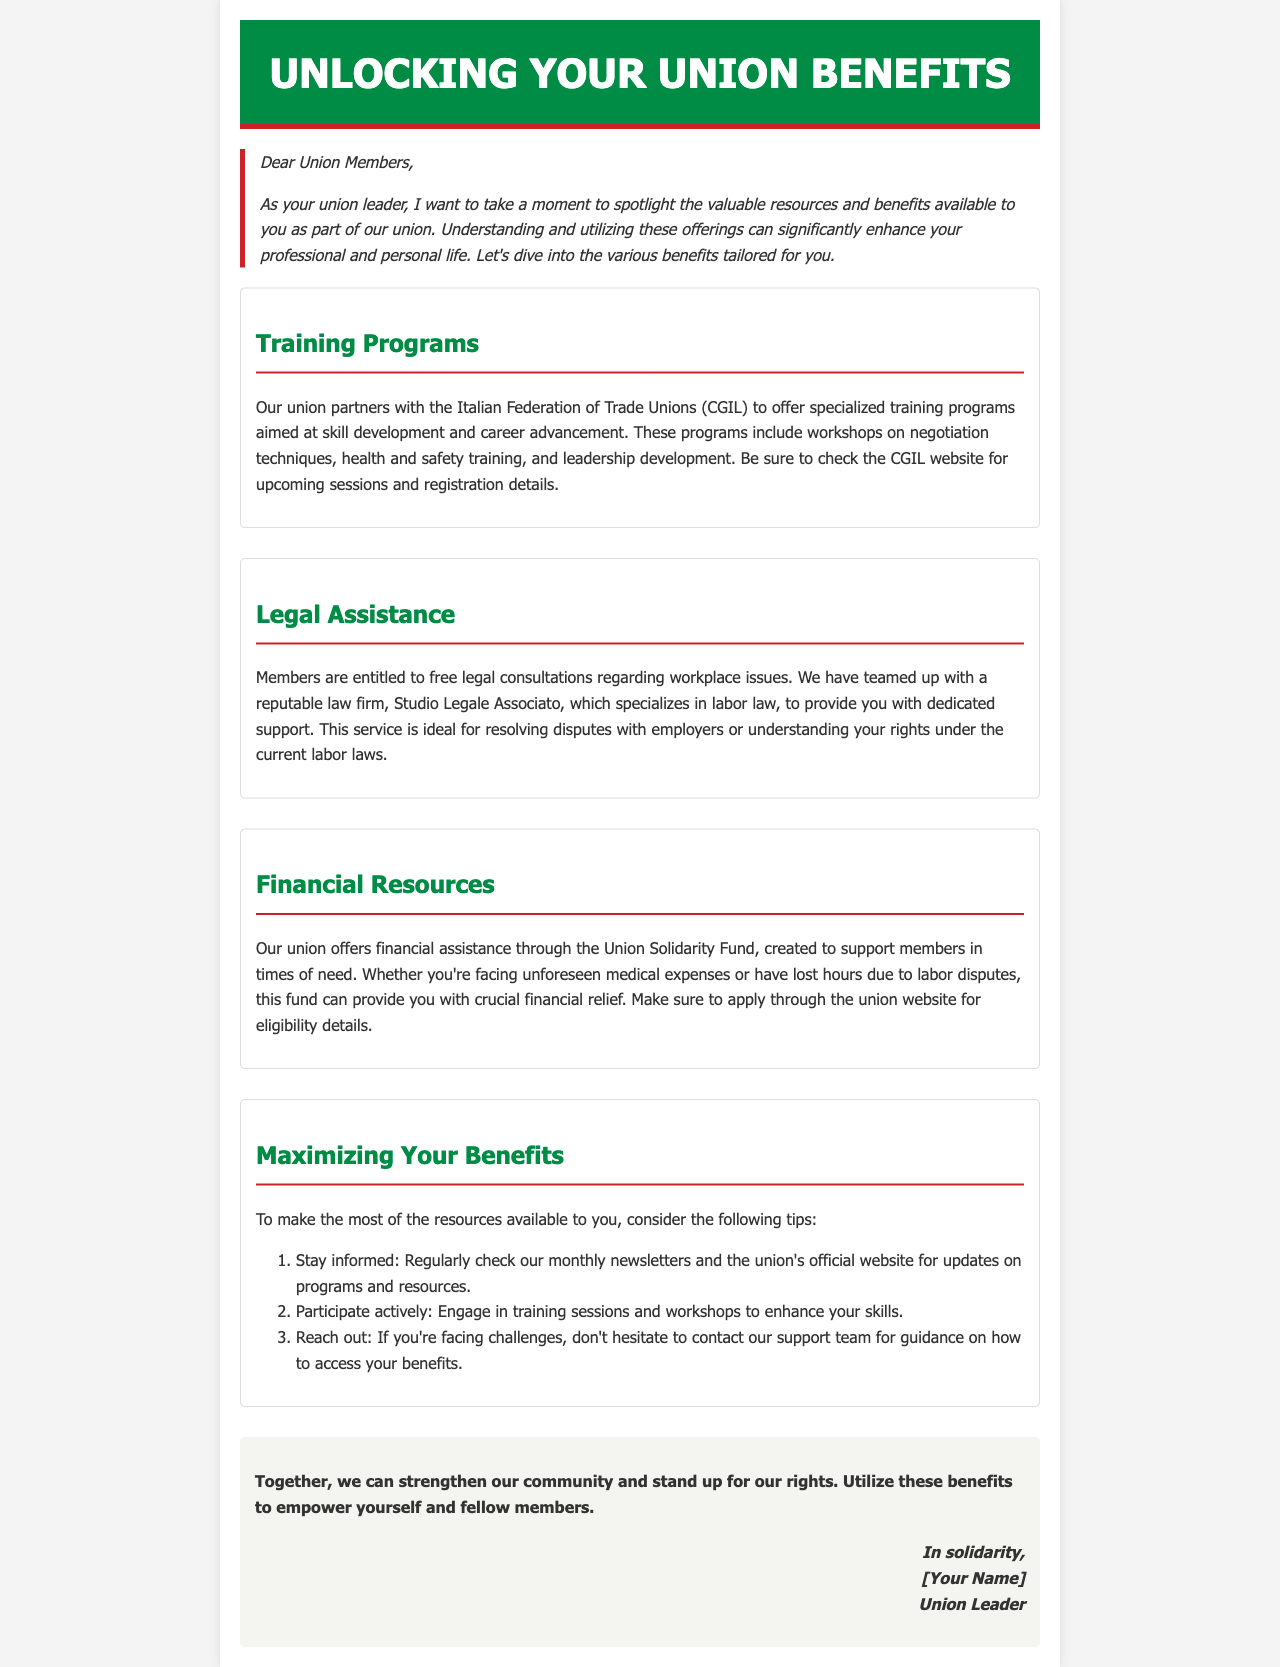What organization partners with the union for training programs? The document states that the union partners with the Italian Federation of Trade Unions (CGIL) for training programs.
Answer: CGIL Who provides legal assistance to union members? The document mentions a reputable law firm, Studio Legale Associato, that provides legal assistance to union members.
Answer: Studio Legale Associato What type of financial aid does the union offer? According to the document, the union offers financial assistance through the Union Solidarity Fund.
Answer: Union Solidarity Fund What is one recommended way to maximize union benefits? The document suggests engaging in training sessions and workshops as a way to maximize benefits.
Answer: Participate actively What type of training is included in the training programs? The document specifies negotiation techniques, health and safety training, and leadership development as part of the training programs.
Answer: Negotiation techniques How should members stay informed about union resources? The document recommends checking the monthly newsletters and the union's official website for updates on resources.
Answer: Monthly newsletters and website What is the main purpose of the Union Solidarity Fund? The document mentions that the Union Solidarity Fund supports members in times of need, such as unforeseen medical expenses or lost hours.
Answer: Support members in times of need What document type does this content represent? The structured format of the content indicates that it is a newsletter since it provides updates and information about member benefits.
Answer: Newsletter 